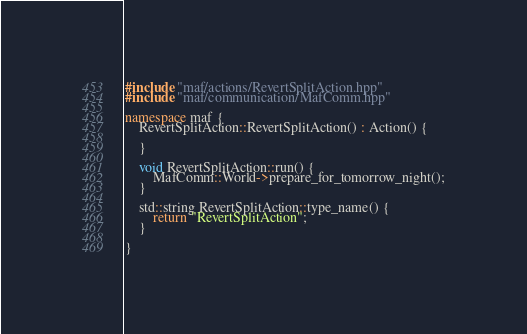Convert code to text. <code><loc_0><loc_0><loc_500><loc_500><_C++_>#include "maf/actions/RevertSplitAction.hpp"
#include "maf/communication/MafComm.hpp"

namespace maf {
    RevertSplitAction::RevertSplitAction() : Action() {

    }

    void RevertSplitAction::run() {
        MafComm::World->prepare_for_tomorrow_night();
    }

    std::string RevertSplitAction::type_name() {
        return "RevertSplitAction";
    }

}
</code> 